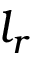Convert formula to latex. <formula><loc_0><loc_0><loc_500><loc_500>l _ { r }</formula> 